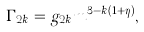<formula> <loc_0><loc_0><loc_500><loc_500>\Gamma _ { 2 k } = g _ { 2 k } m ^ { 3 - k ( 1 + \eta ) } , \\</formula> 